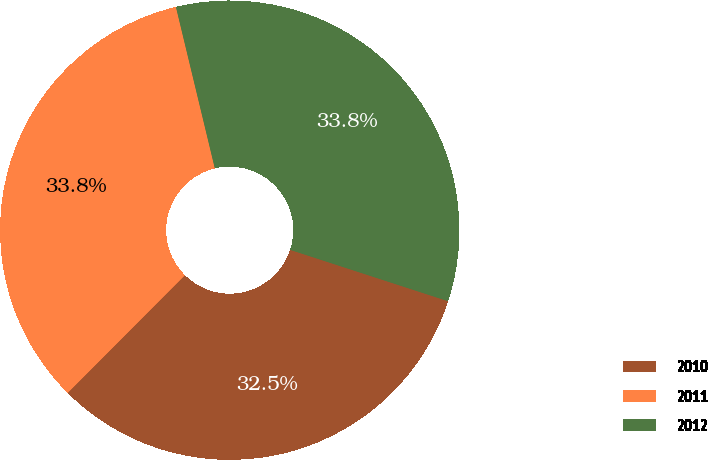Convert chart. <chart><loc_0><loc_0><loc_500><loc_500><pie_chart><fcel>2010<fcel>2011<fcel>2012<nl><fcel>32.47%<fcel>33.77%<fcel>33.77%<nl></chart> 